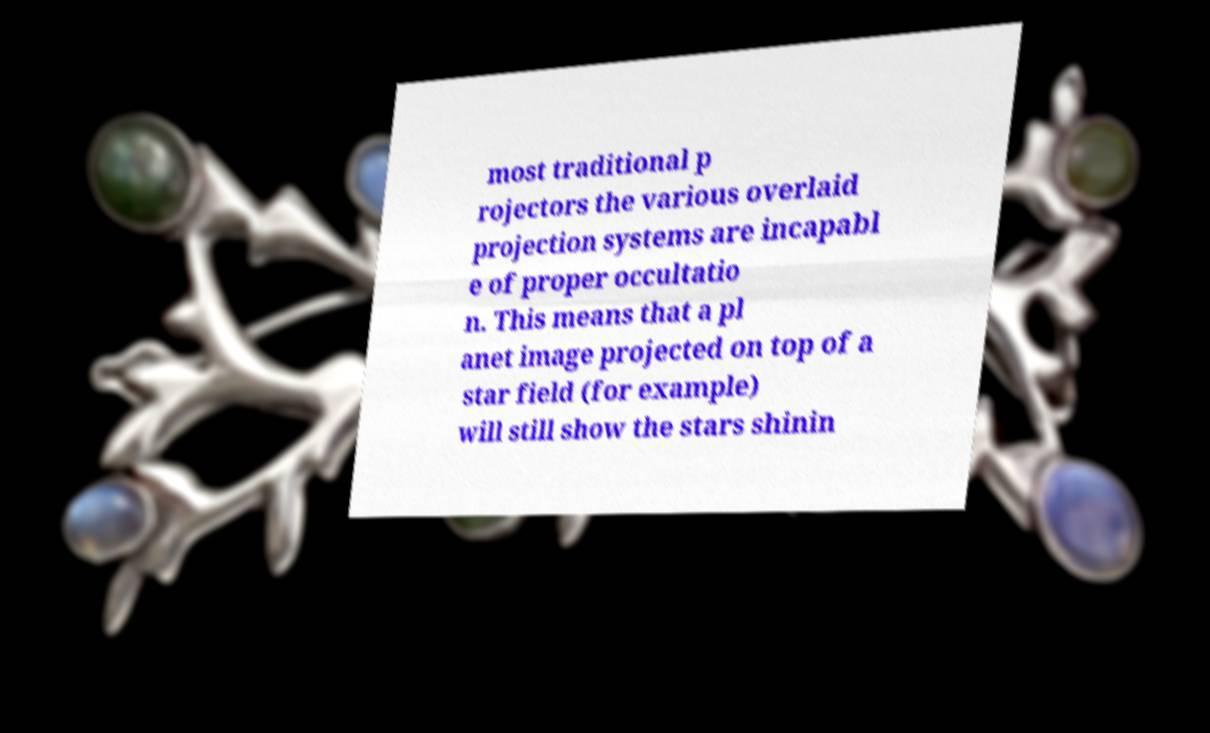Can you read and provide the text displayed in the image?This photo seems to have some interesting text. Can you extract and type it out for me? most traditional p rojectors the various overlaid projection systems are incapabl e of proper occultatio n. This means that a pl anet image projected on top of a star field (for example) will still show the stars shinin 